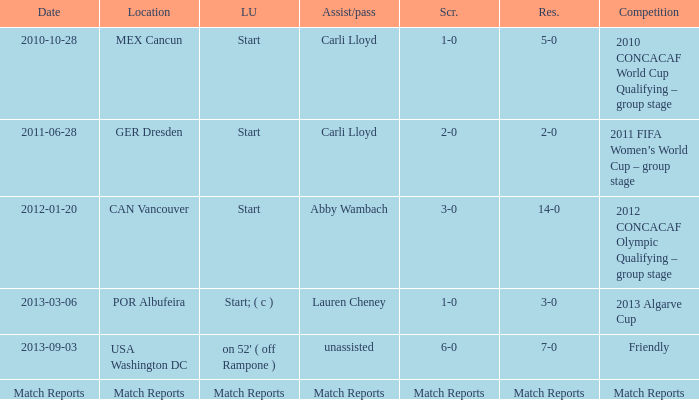Which Assist/pass has a Score of 1-0,a Competition of 2010 concacaf world cup qualifying – group stage? Carli Lloyd. 